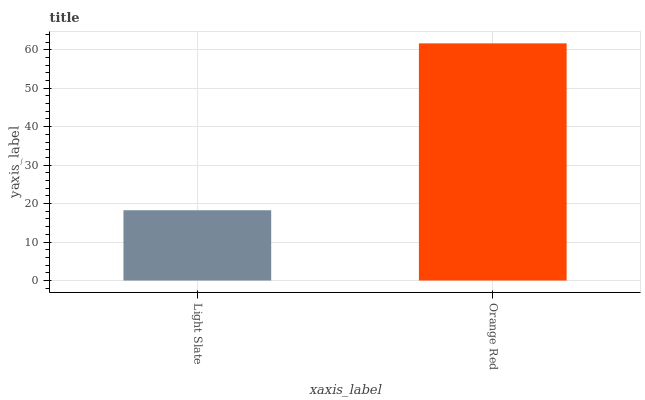Is Light Slate the minimum?
Answer yes or no. Yes. Is Orange Red the maximum?
Answer yes or no. Yes. Is Orange Red the minimum?
Answer yes or no. No. Is Orange Red greater than Light Slate?
Answer yes or no. Yes. Is Light Slate less than Orange Red?
Answer yes or no. Yes. Is Light Slate greater than Orange Red?
Answer yes or no. No. Is Orange Red less than Light Slate?
Answer yes or no. No. Is Orange Red the high median?
Answer yes or no. Yes. Is Light Slate the low median?
Answer yes or no. Yes. Is Light Slate the high median?
Answer yes or no. No. Is Orange Red the low median?
Answer yes or no. No. 